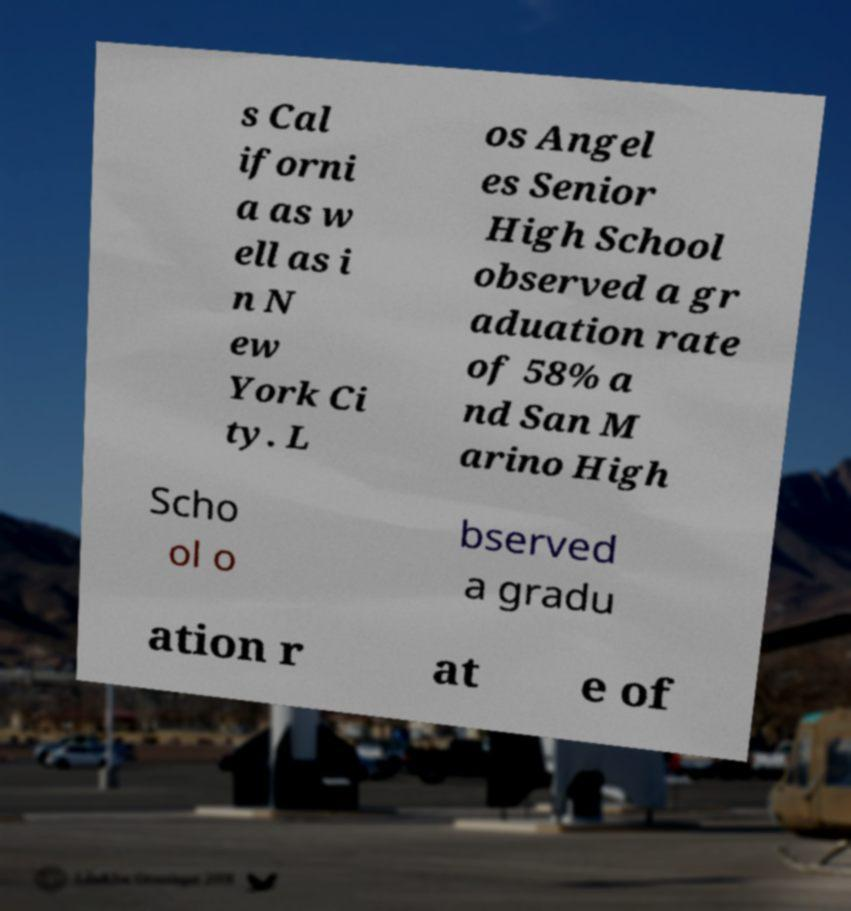Please read and relay the text visible in this image. What does it say? s Cal iforni a as w ell as i n N ew York Ci ty. L os Angel es Senior High School observed a gr aduation rate of 58% a nd San M arino High Scho ol o bserved a gradu ation r at e of 